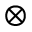Convert formula to latex. <formula><loc_0><loc_0><loc_500><loc_500>\otimes</formula> 